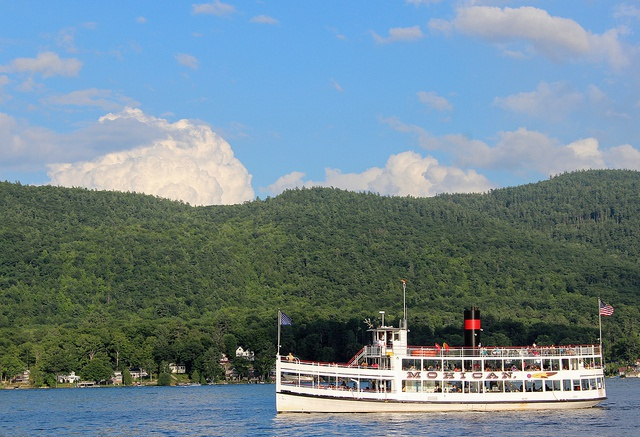Describe the objects in this image and their specific colors. I can see boat in lightblue, ivory, gray, black, and darkgray tones, people in lightblue, tan, brown, black, and darkgray tones, people in lightblue, black, maroon, and brown tones, people in lightblue, gray, black, and tan tones, and people in lightblue, gray, and maroon tones in this image. 